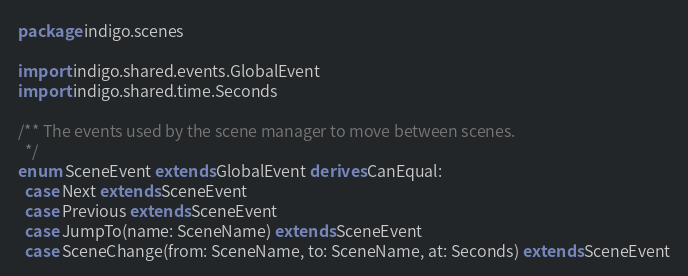<code> <loc_0><loc_0><loc_500><loc_500><_Scala_>package indigo.scenes

import indigo.shared.events.GlobalEvent
import indigo.shared.time.Seconds

/** The events used by the scene manager to move between scenes.
  */
enum SceneEvent extends GlobalEvent derives CanEqual:
  case Next extends SceneEvent
  case Previous extends SceneEvent
  case JumpTo(name: SceneName) extends SceneEvent
  case SceneChange(from: SceneName, to: SceneName, at: Seconds) extends SceneEvent
</code> 